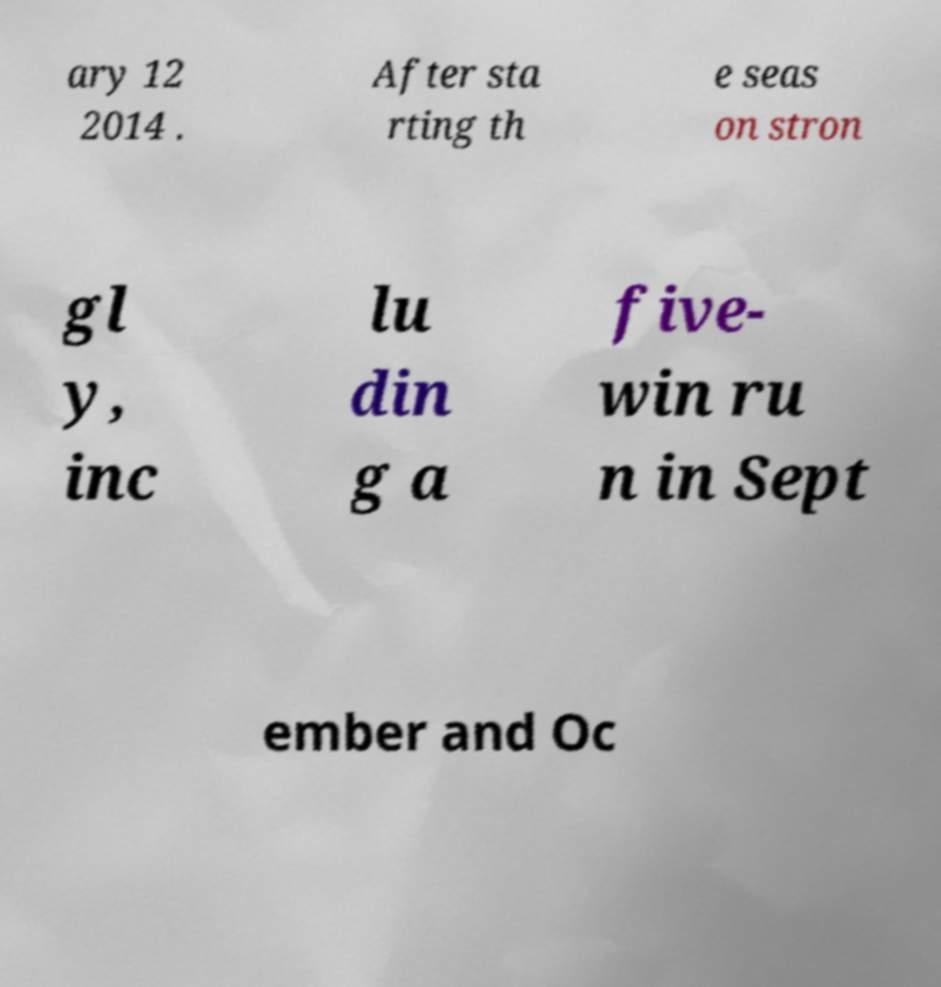Please identify and transcribe the text found in this image. ary 12 2014 . After sta rting th e seas on stron gl y, inc lu din g a five- win ru n in Sept ember and Oc 